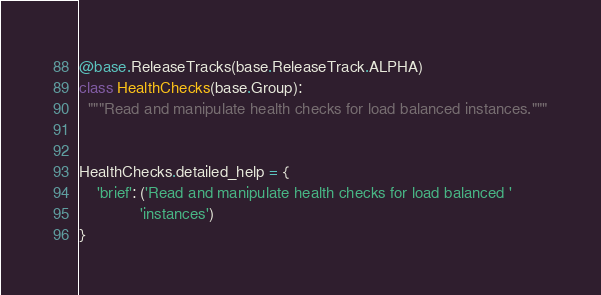<code> <loc_0><loc_0><loc_500><loc_500><_Python_>

@base.ReleaseTracks(base.ReleaseTrack.ALPHA)
class HealthChecks(base.Group):
  """Read and manipulate health checks for load balanced instances."""


HealthChecks.detailed_help = {
    'brief': ('Read and manipulate health checks for load balanced '
              'instances')
}
</code> 